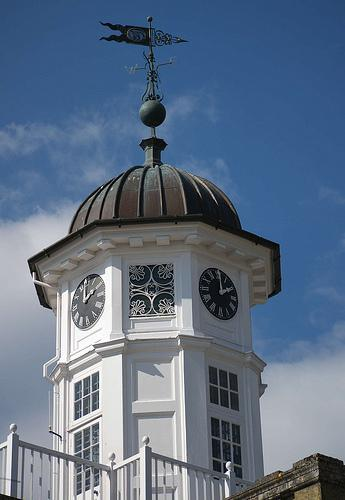Question: what color are the clock?
Choices:
A. Silver.
B. White.
C. Black.
D. Grey.
Answer with the letter. Answer: C Question: what time does the clock say it is?
Choices:
A. 4:00.
B. 2:15.
C. Two o'clock.
D. 5:30.
Answer with the letter. Answer: C Question: how many people are in this picture?
Choices:
A. Zero.
B. Two.
C. Five.
D. Three.
Answer with the letter. Answer: A 